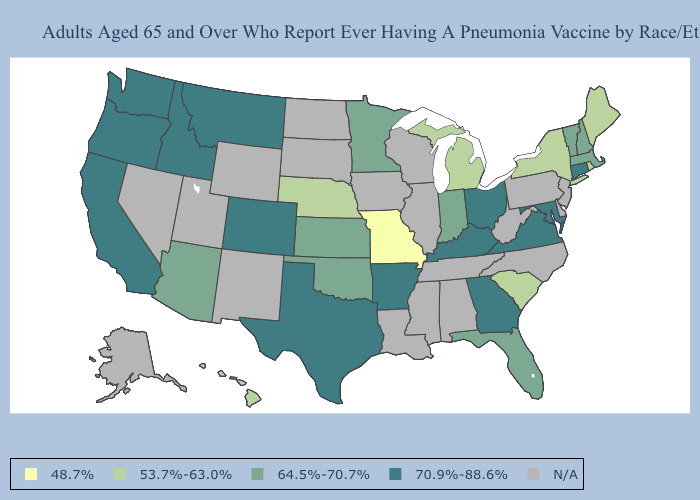Name the states that have a value in the range 70.9%-88.6%?
Quick response, please. Arkansas, California, Colorado, Connecticut, Georgia, Idaho, Kentucky, Maryland, Montana, Ohio, Oregon, Texas, Virginia, Washington. Does Massachusetts have the lowest value in the Northeast?
Concise answer only. No. What is the value of Oklahoma?
Write a very short answer. 64.5%-70.7%. What is the lowest value in states that border Tennessee?
Keep it brief. 48.7%. What is the value of Louisiana?
Be succinct. N/A. Name the states that have a value in the range N/A?
Answer briefly. Alabama, Alaska, Delaware, Illinois, Iowa, Louisiana, Mississippi, Nevada, New Jersey, New Mexico, North Carolina, North Dakota, Pennsylvania, South Dakota, Tennessee, Utah, West Virginia, Wisconsin, Wyoming. What is the lowest value in the USA?
Write a very short answer. 48.7%. Is the legend a continuous bar?
Concise answer only. No. What is the value of Ohio?
Keep it brief. 70.9%-88.6%. Name the states that have a value in the range N/A?
Answer briefly. Alabama, Alaska, Delaware, Illinois, Iowa, Louisiana, Mississippi, Nevada, New Jersey, New Mexico, North Carolina, North Dakota, Pennsylvania, South Dakota, Tennessee, Utah, West Virginia, Wisconsin, Wyoming. Among the states that border Illinois , does Kentucky have the lowest value?
Write a very short answer. No. Name the states that have a value in the range 53.7%-63.0%?
Concise answer only. Hawaii, Maine, Michigan, Nebraska, New York, Rhode Island, South Carolina. What is the value of Colorado?
Give a very brief answer. 70.9%-88.6%. Name the states that have a value in the range 70.9%-88.6%?
Short answer required. Arkansas, California, Colorado, Connecticut, Georgia, Idaho, Kentucky, Maryland, Montana, Ohio, Oregon, Texas, Virginia, Washington. What is the value of Idaho?
Write a very short answer. 70.9%-88.6%. 